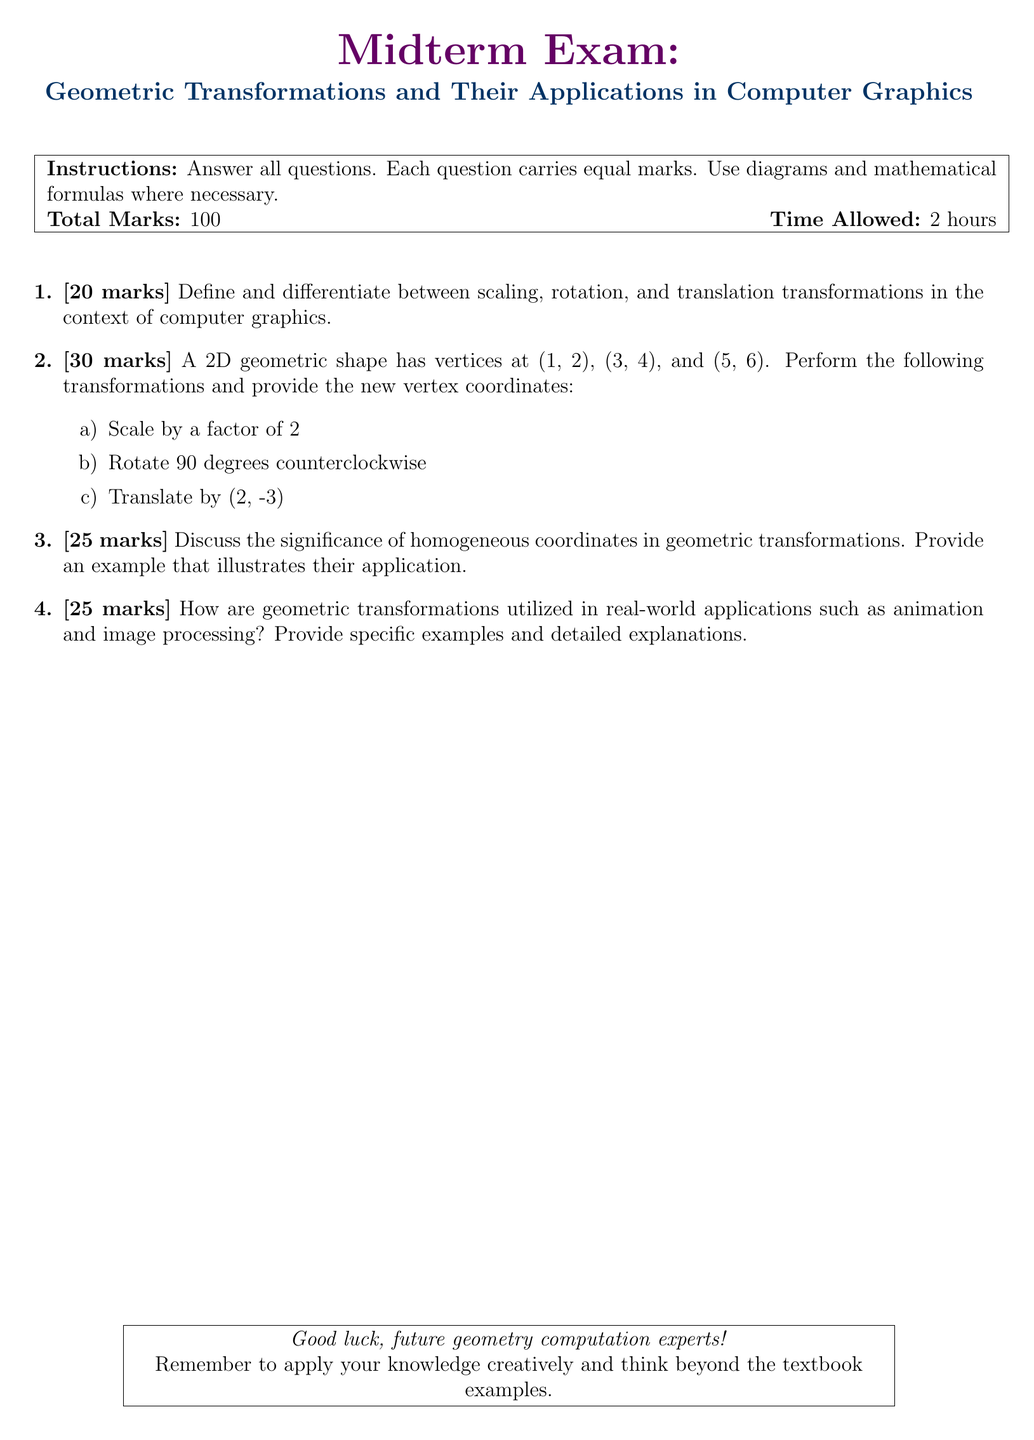What is the total marks for the exam? The total marks is stated in the instructions section of the document.
Answer: 100 What is the time allowed for the exam? The time allowed is mentioned alongside the total marks.
Answer: 2 hours How many marks are assigned to the second question? The number of marks for each question is clearly indicated next to the question number.
Answer: 30 marks What geometric transformation involves changing the size of a shape? The transformation that changes the size is defined in the first question.
Answer: Scaling What are the new vertex coordinates after scaling by a factor of 2? The answer can be derived from the transformations required in question 2a.
Answer: (2, 4), (6, 8), (10, 12) What is the main significance discussed about homogeneous coordinates? The significance of homogeneous coordinates can be found in the context specified in question 3.
Answer: They enable efficient geometric transformations What application of geometric transformations is mentioned in the midterm exam? The application of geometric transformations in a real-world scenario is detailed in question 4.
Answer: Animation How many transformations are required in question 2? The question specifies three transformations to be performed.
Answer: 3 Which specific transform is requested to analyze in question 3? The question explicitly asks for a discussion and example of homogeneous coordinates.
Answer: Homogeneous coordinates 